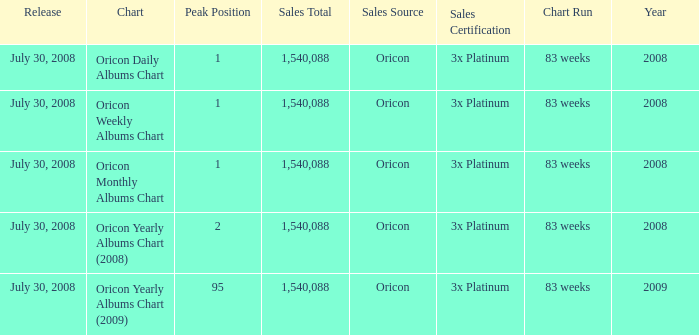Which Chart has a Peak Position of 1? Oricon Daily Albums Chart, Oricon Weekly Albums Chart, Oricon Monthly Albums Chart. 